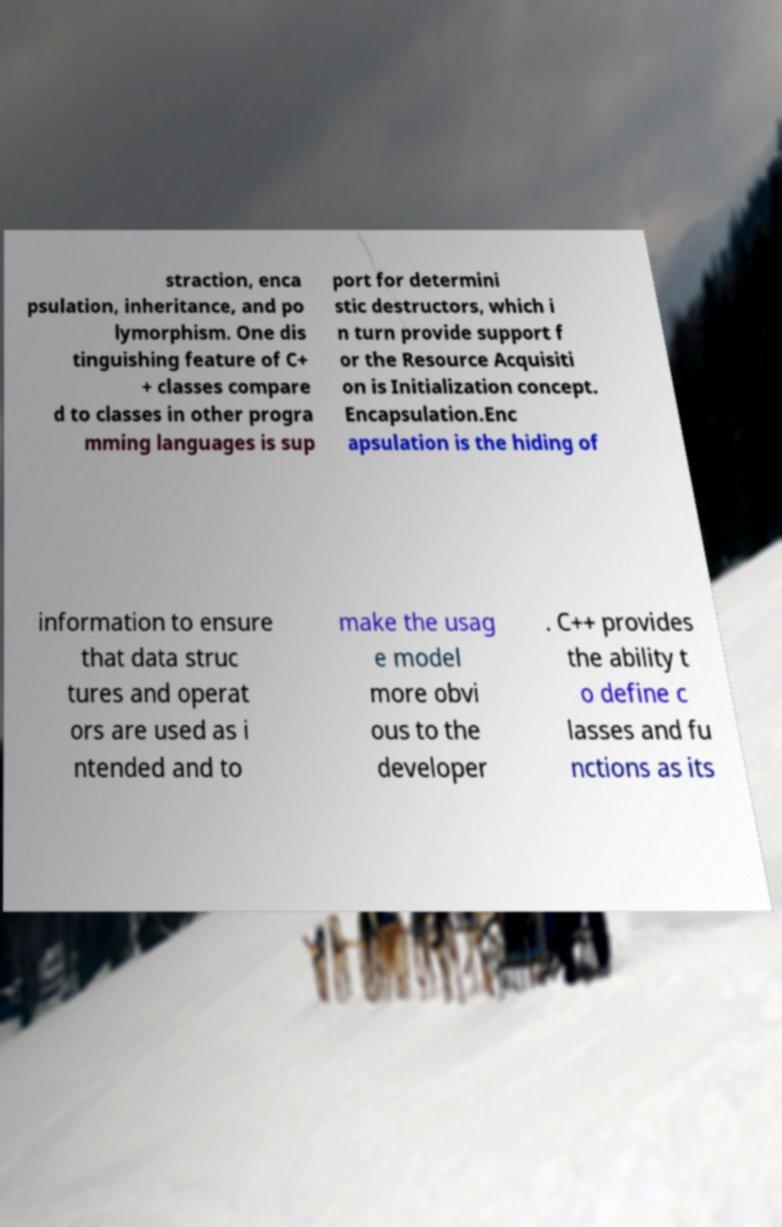Can you accurately transcribe the text from the provided image for me? straction, enca psulation, inheritance, and po lymorphism. One dis tinguishing feature of C+ + classes compare d to classes in other progra mming languages is sup port for determini stic destructors, which i n turn provide support f or the Resource Acquisiti on is Initialization concept. Encapsulation.Enc apsulation is the hiding of information to ensure that data struc tures and operat ors are used as i ntended and to make the usag e model more obvi ous to the developer . C++ provides the ability t o define c lasses and fu nctions as its 